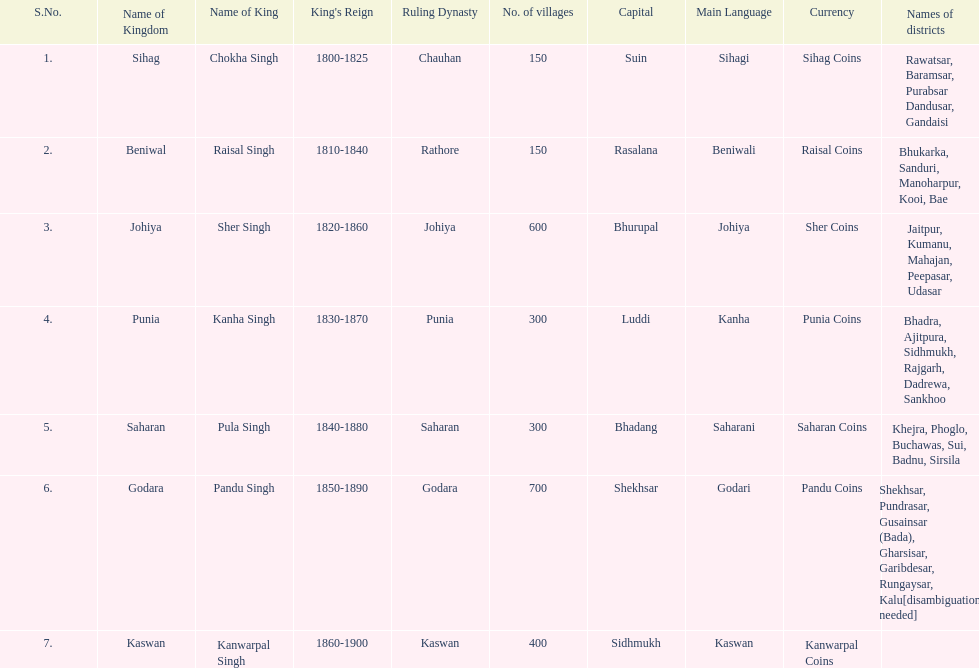What is the number of kingdoms that have more than 300 villages? 3. 